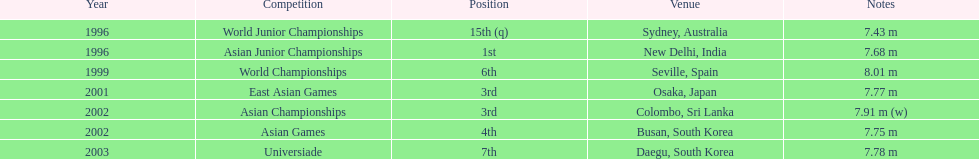I'm looking to parse the entire table for insights. Could you assist me with that? {'header': ['Year', 'Competition', 'Position', 'Venue', 'Notes'], 'rows': [['1996', 'World Junior Championships', '15th (q)', 'Sydney, Australia', '7.43 m'], ['1996', 'Asian Junior Championships', '1st', 'New Delhi, India', '7.68 m'], ['1999', 'World Championships', '6th', 'Seville, Spain', '8.01 m'], ['2001', 'East Asian Games', '3rd', 'Osaka, Japan', '7.77 m'], ['2002', 'Asian Championships', '3rd', 'Colombo, Sri Lanka', '7.91 m (w)'], ['2002', 'Asian Games', '4th', 'Busan, South Korea', '7.75 m'], ['2003', 'Universiade', '7th', 'Daegu, South Korea', '7.78 m']]} Which year was his best jump? 1999. 